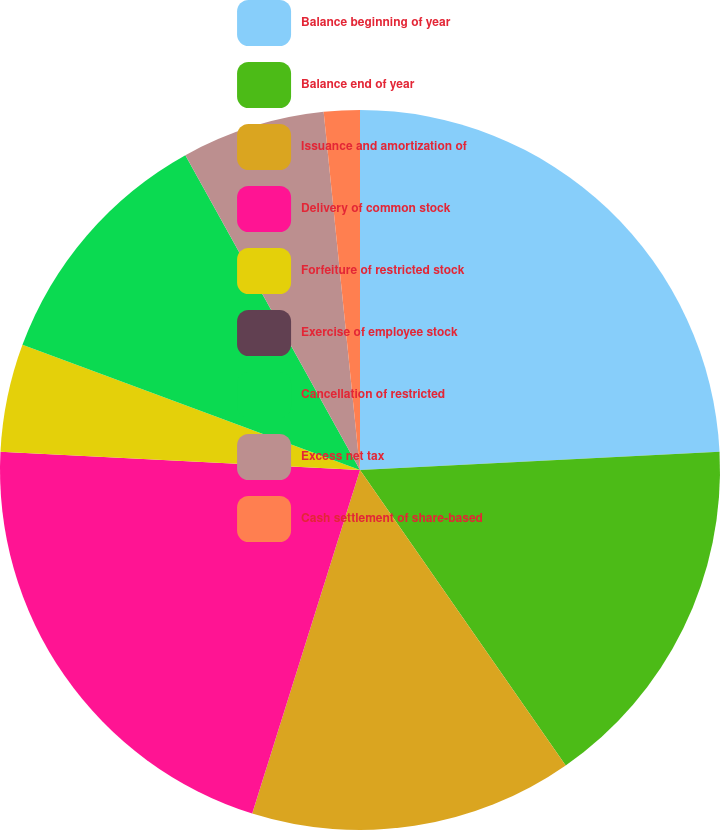Convert chart to OTSL. <chart><loc_0><loc_0><loc_500><loc_500><pie_chart><fcel>Balance beginning of year<fcel>Balance end of year<fcel>Issuance and amortization of<fcel>Delivery of common stock<fcel>Forfeiture of restricted stock<fcel>Exercise of employee stock<fcel>Cancellation of restricted<fcel>Excess net tax<fcel>Cash settlement of share-based<nl><fcel>24.19%<fcel>16.13%<fcel>14.52%<fcel>20.97%<fcel>4.84%<fcel>0.0%<fcel>11.29%<fcel>6.45%<fcel>1.61%<nl></chart> 